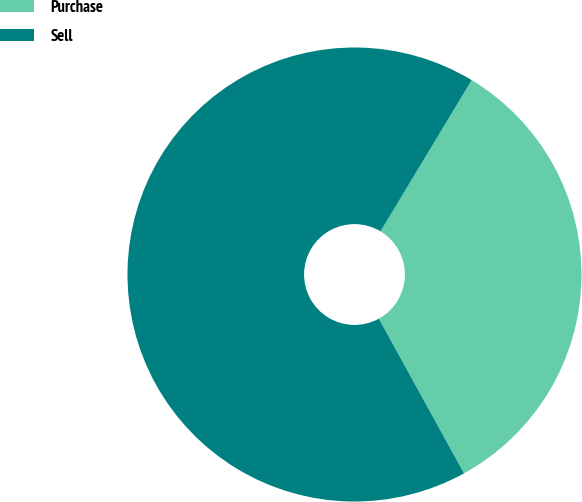<chart> <loc_0><loc_0><loc_500><loc_500><pie_chart><fcel>Purchase<fcel>Sell<nl><fcel>33.35%<fcel>66.65%<nl></chart> 